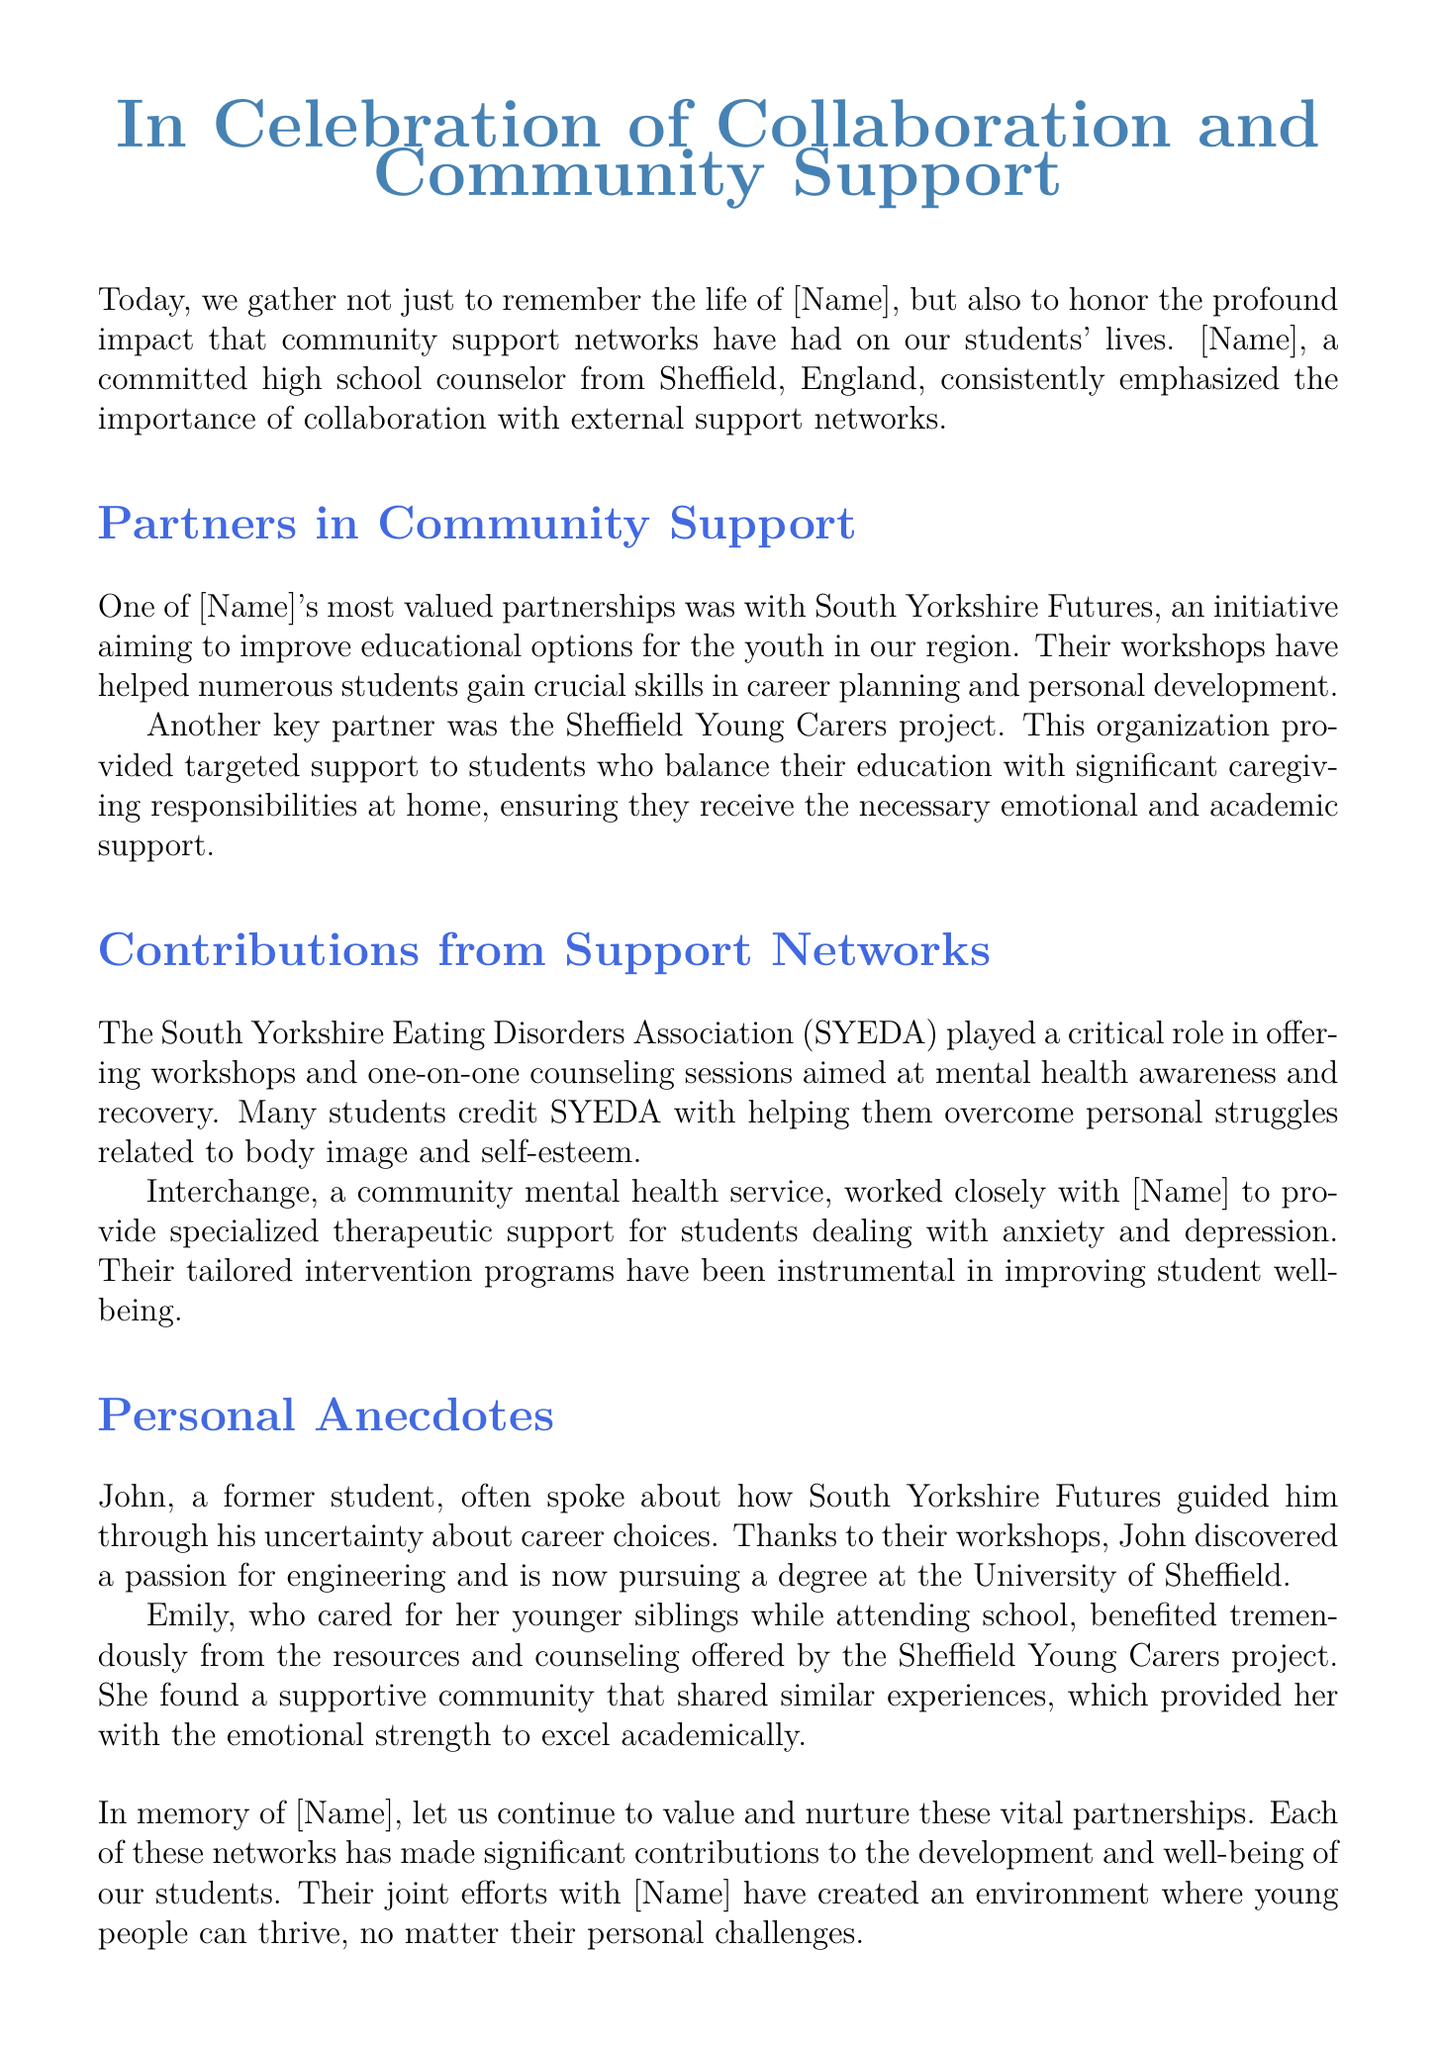What is the title of the document? The title is prominently stated at the beginning of the document, emphasizing the themes of collaboration and community support.
Answer: In Celebration of Collaboration and Community Support Who was a key partner with the high school counselor? The document identifies key partnerships that were crucial in supporting students, highlighting the significant contributions of these networks.
Answer: South Yorkshire Futures What kind of support did the Sheffield Young Carers project provide? The document notes the focus of the Sheffield Young Carers project on helping students manage caregiving responsibilities while ensuring they receive necessary support.
Answer: Targeted support What role did SYEDA play in supporting students? The document describes SYEDA's contributions in offering mental health awareness workshops and counseling to students facing body image and self-esteem issues.
Answer: Critical role Which student discovered a passion for engineering? The personal anecdotes section recounts the experiences of students who benefited from the community support networks, specifically mentioning one student's career journey.
Answer: John How did Emily benefit from Sheffield Young Carers project? The document highlights the specific emotional and academic support provided to Emily, illustrating the positive impact of the project on her education.
Answer: Emotional strength What type of service is Interchange described as? The document characterizes Interchange's support for students, emphasizing its importance in providing mental health services tailored to their needs.
Answer: Community mental health service What is the main purpose of the document? The document serves to honor the contributions of community support networks and the high school counselor's efforts in fostering these collaborations for student well-being.
Answer: To honor contributions 